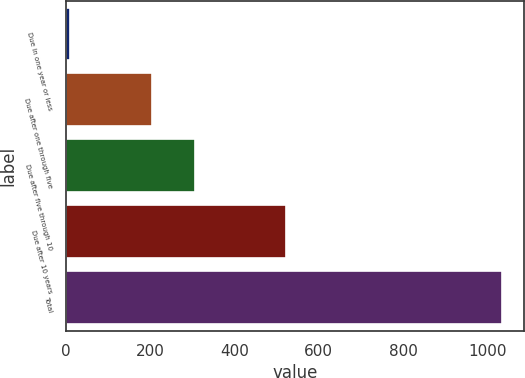Convert chart. <chart><loc_0><loc_0><loc_500><loc_500><bar_chart><fcel>Due in one year or less<fcel>Due after one through five<fcel>Due after five through 10<fcel>Due after 10 years<fcel>Total<nl><fcel>9<fcel>204<fcel>306.5<fcel>521<fcel>1034<nl></chart> 